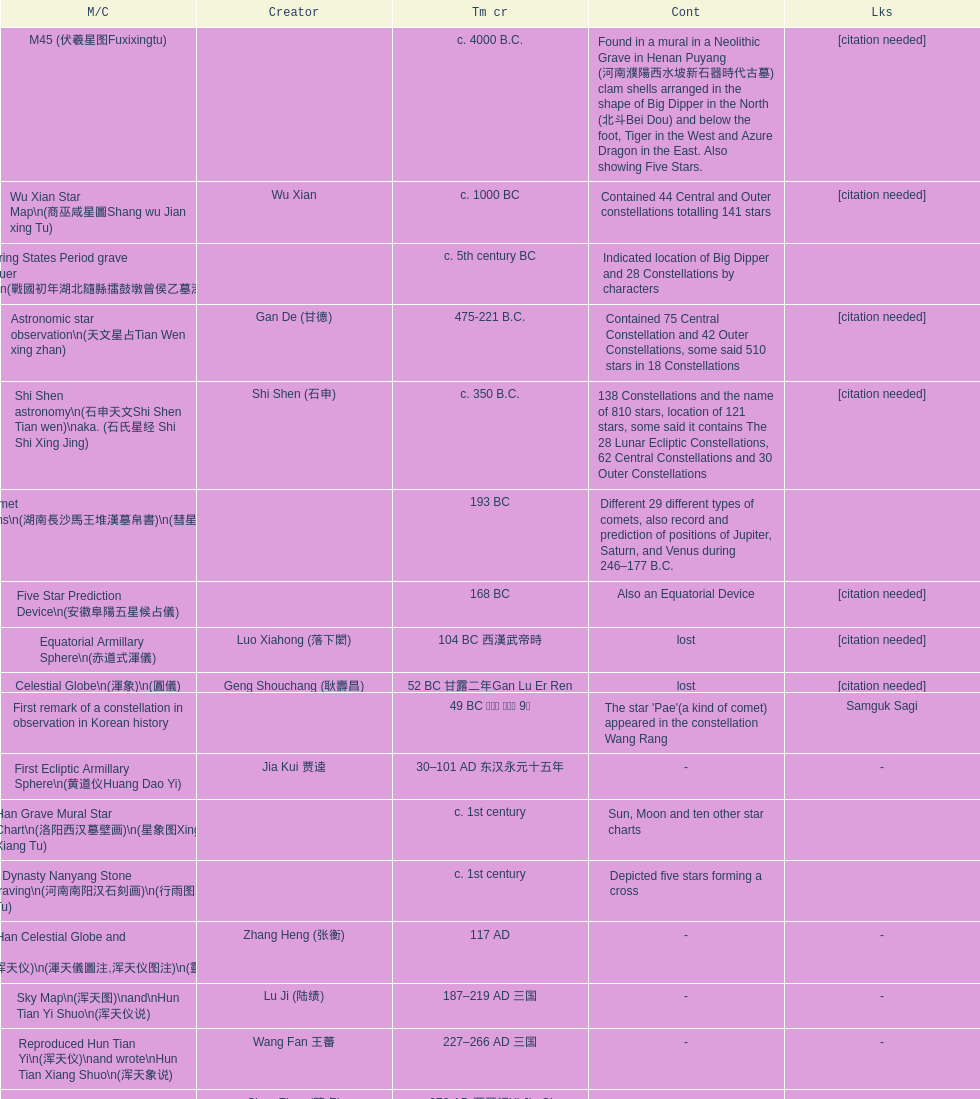Did xu guang ci or su song create the five star charts in 1094 ad? Su Song 蘇頌. 